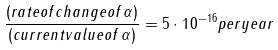Convert formula to latex. <formula><loc_0><loc_0><loc_500><loc_500>\frac { ( r a t e o f c h a n g e o f \, \alpha ) } { ( c u r r e n t v a l u e o f \, \alpha ) } = 5 \cdot 1 0 ^ { - 1 6 } p e r y e a r</formula> 